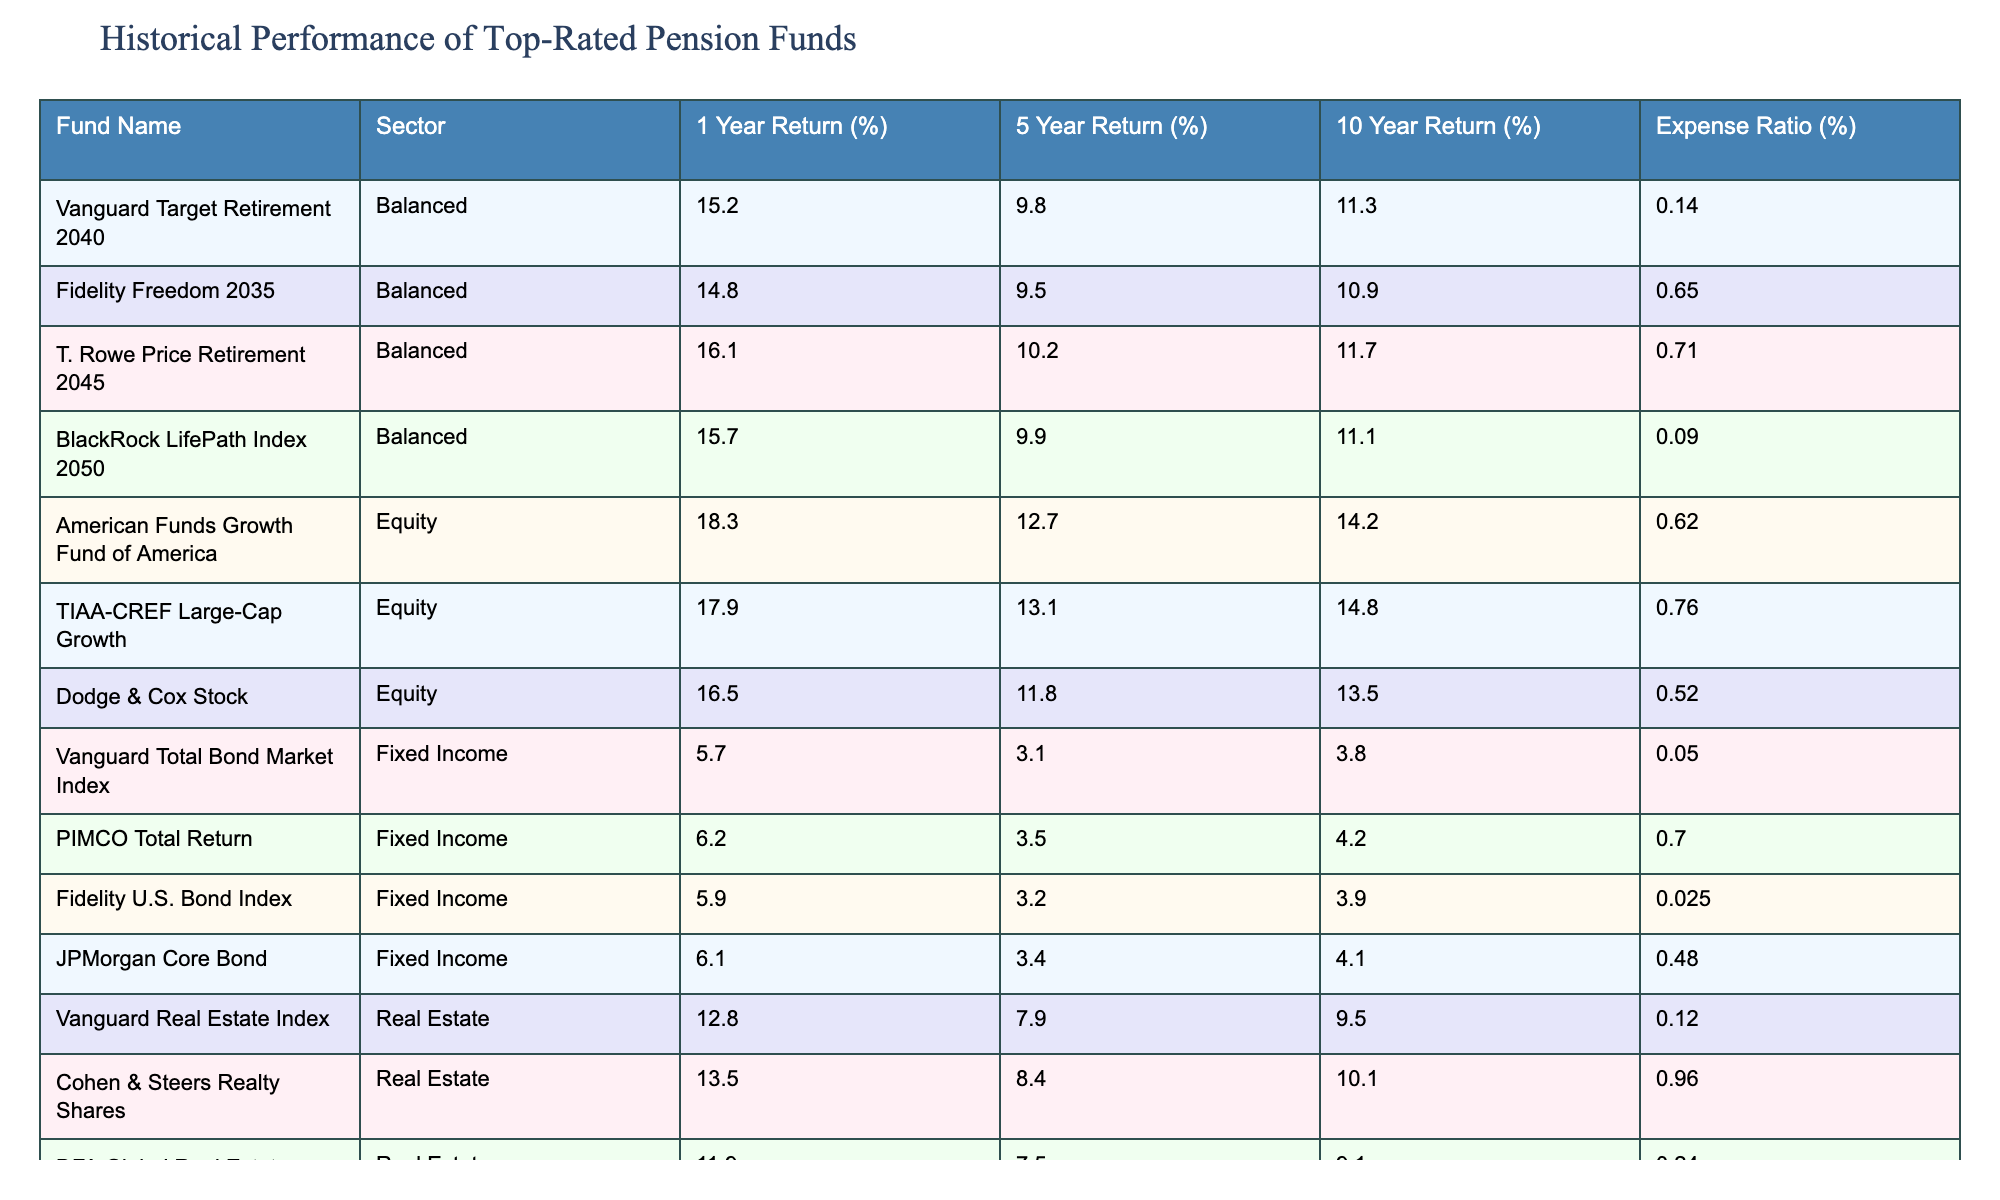What is the highest 1-year return among the pension funds? The table lists the 1-year returns for each fund. The highest value is 18.3% from the American Funds Growth Fund of America.
Answer: 18.3% Which fund has the lowest expense ratio? Looking at the expense ratios in the table, the Vanguard Total Bond Market Index has the lowest expense ratio of 0.05%.
Answer: 0.05% How does the 5-year return of the T. Rowe Price Retirement 2045 compare to that of the Fidelity Freedom 2035? The 5-year return for T. Rowe Price Retirement 2045 is 10.2%, while Fidelity Freedom 2035 has a return of 9.5%. T. Rowe Price Retirement 2045 outperforms by 0.7%.
Answer: 0.7% What is the average 10-year return for the Real Estate sector funds? The table shows 10-year returns of 9.5%, 10.1%, and 9.1% for the three Real Estate funds. The average is (9.5 + 10.1 + 9.1) / 3 = 9.5667%, approximately 9.57%.
Answer: 9.57% Is there a fund in the Equity sector with a 10-year return higher than 14%? The table lists the 10-year returns for the Equity funds. American Funds Growth Fund of America has 14.2%, TIAA-CREF Large-Cap Growth has 14.8%. Both exceed 14%.
Answer: Yes Which Balanced fund has the highest 5-year return and what is that return? Among the Balanced funds, T. Rowe Price Retirement 2045 has the highest 5-year return at 10.2%.
Answer: 10.2% Calculate the difference in the 1-year return between the top-performing fund in Equity and the top-performing fund in Fixed Income. The top-performing Equity fund has an 18.3% return (American Funds Growth Fund of America) and the top Fixed Income fund has a 6.2% return (PIMCO Total Return). The difference is 18.3 - 6.2 = 12.1%.
Answer: 12.1% Is the expense ratio of the BlackRock LifePath Index 2050 fund lower than the average expense ratio of the Balanced sector? The expense ratio for BlackRock LifePath Index 2050 is 0.09%. The average expense ratio for the Balanced funds (Vanguard Target Retirement 2040: 0.14%, Fidelity Freedom 2035: 0.65%, T. Rowe Price Retirement 2045: 0.71%) is (0.14 + 0.65 + 0.71) / 3 = 0.5%. Since 0.09% is less than 0.5%, the statement is true.
Answer: Yes Which sector has the highest average return for the last 10 years? The 10-year returns for Balanced, Equity, Fixed Income, and Real Estate sectors need to be averaged. The averages are 11.0% (Balanced), 14.1% (Equity), 3.6% (Fixed Income), and 9.5% (Real Estate). The Equity sector has the highest average return.
Answer: Equity How much higher is the 1-year return of the Vanguard Real Estate Index compared to the Fidelity U.S. Bond Index? The 1-year return for Vanguard Real Estate Index is 12.8%, and for Fidelity U.S. Bond Index, it's 5.9%. The difference is 12.8 - 5.9 = 6.9%.
Answer: 6.9% 